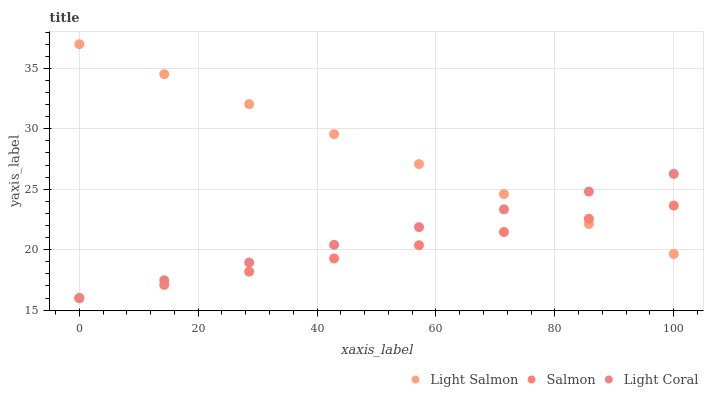Does Salmon have the minimum area under the curve?
Answer yes or no. Yes. Does Light Salmon have the maximum area under the curve?
Answer yes or no. Yes. Does Light Salmon have the minimum area under the curve?
Answer yes or no. No. Does Salmon have the maximum area under the curve?
Answer yes or no. No. Is Salmon the smoothest?
Answer yes or no. Yes. Is Light Salmon the roughest?
Answer yes or no. Yes. Is Light Salmon the smoothest?
Answer yes or no. No. Is Salmon the roughest?
Answer yes or no. No. Does Light Coral have the lowest value?
Answer yes or no. Yes. Does Light Salmon have the lowest value?
Answer yes or no. No. Does Light Salmon have the highest value?
Answer yes or no. Yes. Does Salmon have the highest value?
Answer yes or no. No. Does Salmon intersect Light Coral?
Answer yes or no. Yes. Is Salmon less than Light Coral?
Answer yes or no. No. Is Salmon greater than Light Coral?
Answer yes or no. No. 